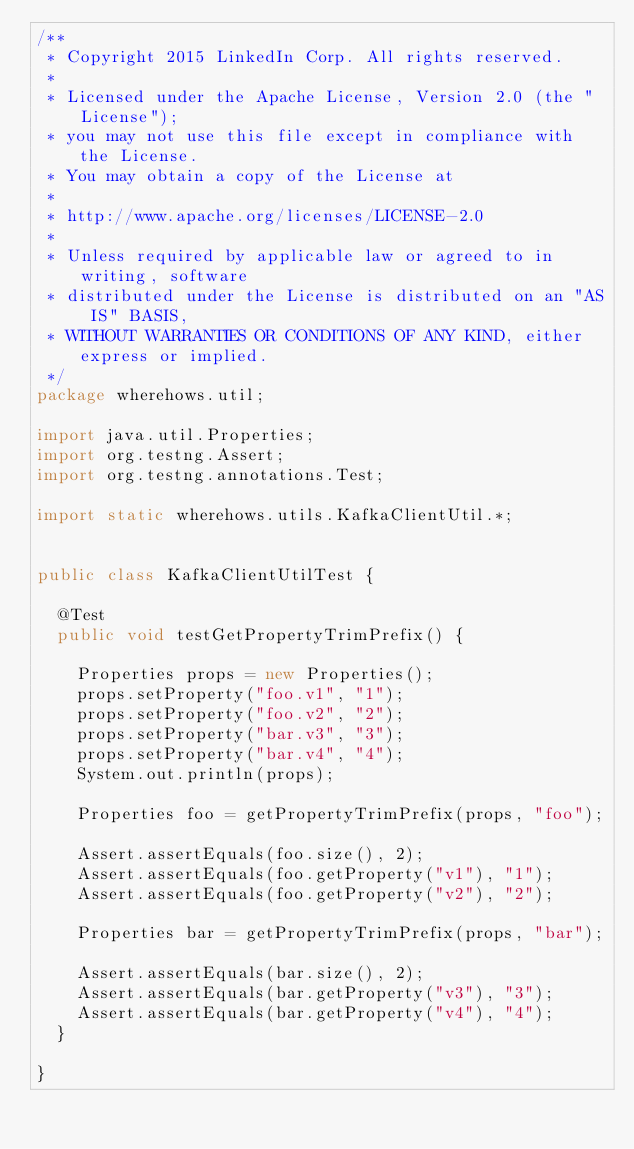Convert code to text. <code><loc_0><loc_0><loc_500><loc_500><_Java_>/**
 * Copyright 2015 LinkedIn Corp. All rights reserved.
 *
 * Licensed under the Apache License, Version 2.0 (the "License");
 * you may not use this file except in compliance with the License.
 * You may obtain a copy of the License at
 *
 * http://www.apache.org/licenses/LICENSE-2.0
 *
 * Unless required by applicable law or agreed to in writing, software
 * distributed under the License is distributed on an "AS IS" BASIS,
 * WITHOUT WARRANTIES OR CONDITIONS OF ANY KIND, either express or implied.
 */
package wherehows.util;

import java.util.Properties;
import org.testng.Assert;
import org.testng.annotations.Test;

import static wherehows.utils.KafkaClientUtil.*;


public class KafkaClientUtilTest {

  @Test
  public void testGetPropertyTrimPrefix() {

    Properties props = new Properties();
    props.setProperty("foo.v1", "1");
    props.setProperty("foo.v2", "2");
    props.setProperty("bar.v3", "3");
    props.setProperty("bar.v4", "4");
    System.out.println(props);

    Properties foo = getPropertyTrimPrefix(props, "foo");

    Assert.assertEquals(foo.size(), 2);
    Assert.assertEquals(foo.getProperty("v1"), "1");
    Assert.assertEquals(foo.getProperty("v2"), "2");

    Properties bar = getPropertyTrimPrefix(props, "bar");

    Assert.assertEquals(bar.size(), 2);
    Assert.assertEquals(bar.getProperty("v3"), "3");
    Assert.assertEquals(bar.getProperty("v4"), "4");
  }

}
</code> 